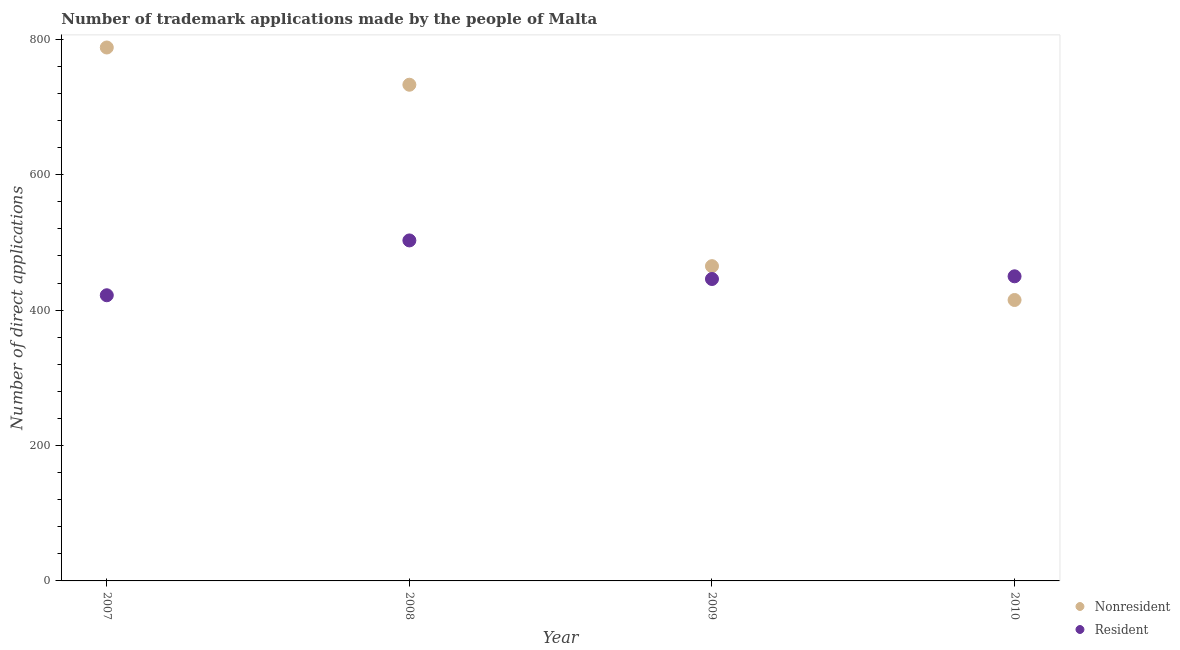What is the number of trademark applications made by non residents in 2009?
Your answer should be very brief. 465. Across all years, what is the maximum number of trademark applications made by non residents?
Make the answer very short. 788. Across all years, what is the minimum number of trademark applications made by non residents?
Offer a terse response. 415. In which year was the number of trademark applications made by residents maximum?
Offer a terse response. 2008. What is the total number of trademark applications made by residents in the graph?
Your response must be concise. 1821. What is the difference between the number of trademark applications made by residents in 2008 and that in 2010?
Offer a very short reply. 53. What is the difference between the number of trademark applications made by non residents in 2010 and the number of trademark applications made by residents in 2009?
Your answer should be compact. -31. What is the average number of trademark applications made by residents per year?
Offer a terse response. 455.25. In the year 2008, what is the difference between the number of trademark applications made by residents and number of trademark applications made by non residents?
Your response must be concise. -230. In how many years, is the number of trademark applications made by residents greater than 520?
Your response must be concise. 0. What is the ratio of the number of trademark applications made by non residents in 2008 to that in 2009?
Offer a terse response. 1.58. Is the number of trademark applications made by residents in 2009 less than that in 2010?
Offer a terse response. Yes. Is the difference between the number of trademark applications made by non residents in 2007 and 2010 greater than the difference between the number of trademark applications made by residents in 2007 and 2010?
Your answer should be compact. Yes. What is the difference between the highest and the second highest number of trademark applications made by non residents?
Give a very brief answer. 55. What is the difference between the highest and the lowest number of trademark applications made by residents?
Offer a very short reply. 81. How many years are there in the graph?
Keep it short and to the point. 4. What is the difference between two consecutive major ticks on the Y-axis?
Offer a very short reply. 200. Are the values on the major ticks of Y-axis written in scientific E-notation?
Your answer should be very brief. No. Does the graph contain grids?
Ensure brevity in your answer.  No. How are the legend labels stacked?
Give a very brief answer. Vertical. What is the title of the graph?
Provide a succinct answer. Number of trademark applications made by the people of Malta. Does "Lower secondary education" appear as one of the legend labels in the graph?
Give a very brief answer. No. What is the label or title of the X-axis?
Keep it short and to the point. Year. What is the label or title of the Y-axis?
Keep it short and to the point. Number of direct applications. What is the Number of direct applications of Nonresident in 2007?
Provide a succinct answer. 788. What is the Number of direct applications in Resident in 2007?
Your answer should be compact. 422. What is the Number of direct applications of Nonresident in 2008?
Provide a succinct answer. 733. What is the Number of direct applications in Resident in 2008?
Provide a short and direct response. 503. What is the Number of direct applications in Nonresident in 2009?
Ensure brevity in your answer.  465. What is the Number of direct applications of Resident in 2009?
Your answer should be very brief. 446. What is the Number of direct applications in Nonresident in 2010?
Give a very brief answer. 415. What is the Number of direct applications in Resident in 2010?
Provide a succinct answer. 450. Across all years, what is the maximum Number of direct applications in Nonresident?
Your answer should be very brief. 788. Across all years, what is the maximum Number of direct applications of Resident?
Offer a terse response. 503. Across all years, what is the minimum Number of direct applications in Nonresident?
Provide a succinct answer. 415. Across all years, what is the minimum Number of direct applications in Resident?
Your response must be concise. 422. What is the total Number of direct applications in Nonresident in the graph?
Keep it short and to the point. 2401. What is the total Number of direct applications of Resident in the graph?
Provide a succinct answer. 1821. What is the difference between the Number of direct applications of Nonresident in 2007 and that in 2008?
Your answer should be very brief. 55. What is the difference between the Number of direct applications of Resident in 2007 and that in 2008?
Make the answer very short. -81. What is the difference between the Number of direct applications in Nonresident in 2007 and that in 2009?
Keep it short and to the point. 323. What is the difference between the Number of direct applications of Nonresident in 2007 and that in 2010?
Keep it short and to the point. 373. What is the difference between the Number of direct applications of Resident in 2007 and that in 2010?
Your response must be concise. -28. What is the difference between the Number of direct applications in Nonresident in 2008 and that in 2009?
Your response must be concise. 268. What is the difference between the Number of direct applications in Nonresident in 2008 and that in 2010?
Give a very brief answer. 318. What is the difference between the Number of direct applications in Resident in 2008 and that in 2010?
Your answer should be very brief. 53. What is the difference between the Number of direct applications of Nonresident in 2007 and the Number of direct applications of Resident in 2008?
Ensure brevity in your answer.  285. What is the difference between the Number of direct applications in Nonresident in 2007 and the Number of direct applications in Resident in 2009?
Your answer should be very brief. 342. What is the difference between the Number of direct applications of Nonresident in 2007 and the Number of direct applications of Resident in 2010?
Offer a very short reply. 338. What is the difference between the Number of direct applications in Nonresident in 2008 and the Number of direct applications in Resident in 2009?
Ensure brevity in your answer.  287. What is the difference between the Number of direct applications in Nonresident in 2008 and the Number of direct applications in Resident in 2010?
Provide a short and direct response. 283. What is the difference between the Number of direct applications in Nonresident in 2009 and the Number of direct applications in Resident in 2010?
Ensure brevity in your answer.  15. What is the average Number of direct applications of Nonresident per year?
Keep it short and to the point. 600.25. What is the average Number of direct applications in Resident per year?
Offer a terse response. 455.25. In the year 2007, what is the difference between the Number of direct applications in Nonresident and Number of direct applications in Resident?
Ensure brevity in your answer.  366. In the year 2008, what is the difference between the Number of direct applications of Nonresident and Number of direct applications of Resident?
Provide a short and direct response. 230. In the year 2009, what is the difference between the Number of direct applications in Nonresident and Number of direct applications in Resident?
Offer a very short reply. 19. In the year 2010, what is the difference between the Number of direct applications in Nonresident and Number of direct applications in Resident?
Give a very brief answer. -35. What is the ratio of the Number of direct applications in Nonresident in 2007 to that in 2008?
Keep it short and to the point. 1.07. What is the ratio of the Number of direct applications of Resident in 2007 to that in 2008?
Your answer should be compact. 0.84. What is the ratio of the Number of direct applications of Nonresident in 2007 to that in 2009?
Your answer should be compact. 1.69. What is the ratio of the Number of direct applications in Resident in 2007 to that in 2009?
Your answer should be very brief. 0.95. What is the ratio of the Number of direct applications in Nonresident in 2007 to that in 2010?
Give a very brief answer. 1.9. What is the ratio of the Number of direct applications in Resident in 2007 to that in 2010?
Keep it short and to the point. 0.94. What is the ratio of the Number of direct applications in Nonresident in 2008 to that in 2009?
Provide a short and direct response. 1.58. What is the ratio of the Number of direct applications of Resident in 2008 to that in 2009?
Give a very brief answer. 1.13. What is the ratio of the Number of direct applications of Nonresident in 2008 to that in 2010?
Ensure brevity in your answer.  1.77. What is the ratio of the Number of direct applications of Resident in 2008 to that in 2010?
Give a very brief answer. 1.12. What is the ratio of the Number of direct applications in Nonresident in 2009 to that in 2010?
Your response must be concise. 1.12. What is the ratio of the Number of direct applications of Resident in 2009 to that in 2010?
Make the answer very short. 0.99. What is the difference between the highest and the second highest Number of direct applications of Nonresident?
Ensure brevity in your answer.  55. What is the difference between the highest and the second highest Number of direct applications in Resident?
Your answer should be compact. 53. What is the difference between the highest and the lowest Number of direct applications in Nonresident?
Offer a terse response. 373. What is the difference between the highest and the lowest Number of direct applications in Resident?
Your answer should be compact. 81. 